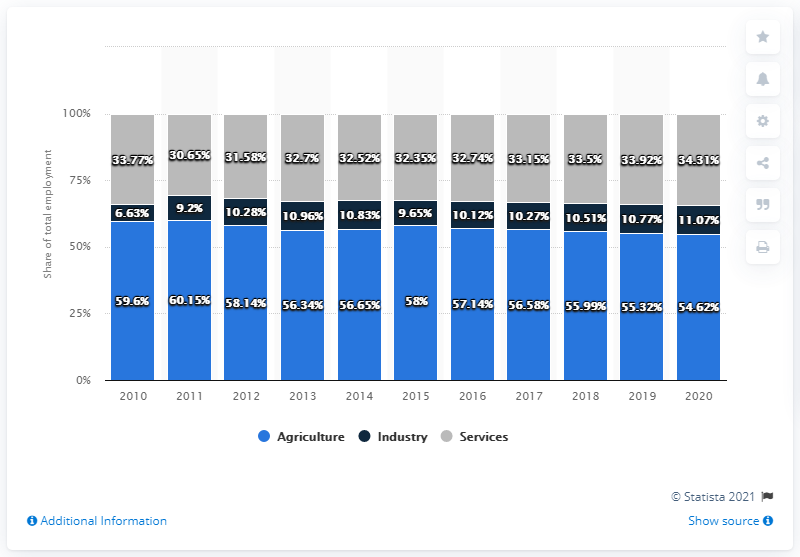Indicate a few pertinent items in this graphic. The total average for agriculture and industry in the economic sector in 2020 was 65.69. In 2020, the agriculture percentage was 54.62%. 